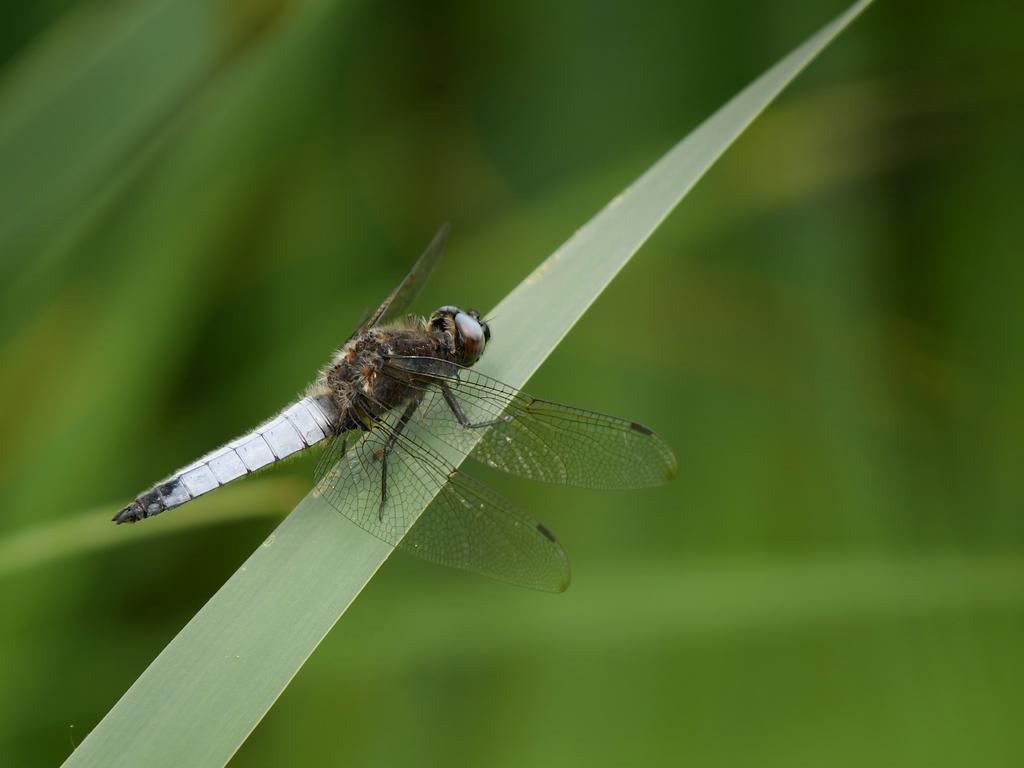Please provide a concise description of this image. In this image there is a dragonfly on grass, in the background it is blurred. 